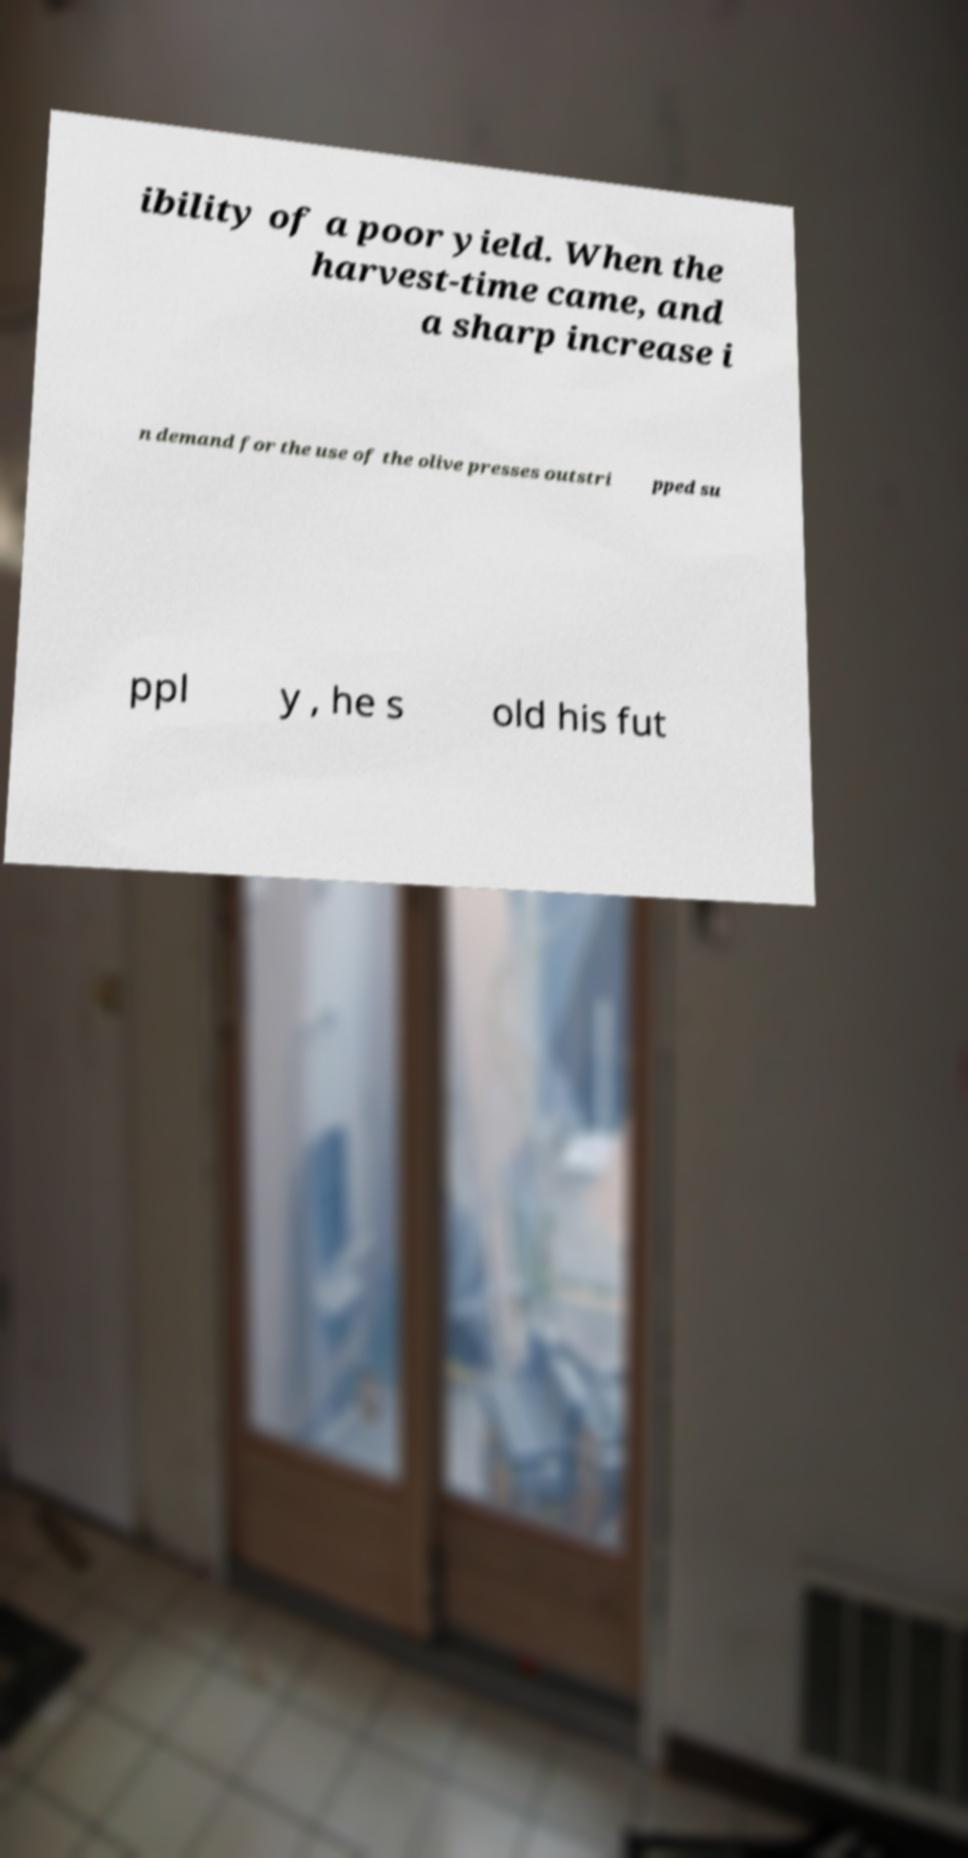Can you read and provide the text displayed in the image?This photo seems to have some interesting text. Can you extract and type it out for me? ibility of a poor yield. When the harvest-time came, and a sharp increase i n demand for the use of the olive presses outstri pped su ppl y , he s old his fut 